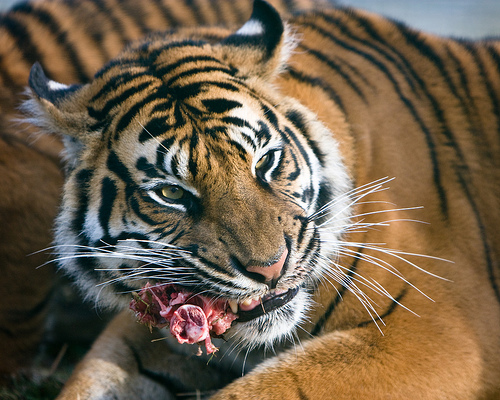<image>
Is the meat under the tiger? No. The meat is not positioned under the tiger. The vertical relationship between these objects is different. Where is the tiger in relation to the meat? Is it next to the meat? No. The tiger is not positioned next to the meat. They are located in different areas of the scene. Is there a tiger above the food? No. The tiger is not positioned above the food. The vertical arrangement shows a different relationship. 